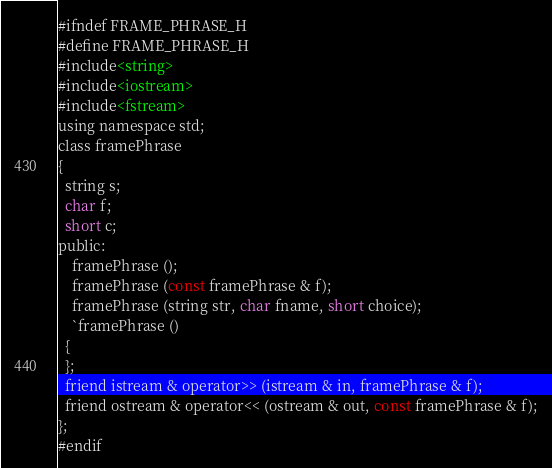Convert code to text. <code><loc_0><loc_0><loc_500><loc_500><_C_>#ifndef FRAME_PHRASE_H
#define FRAME_PHRASE_H
#include<string>
#include<iostream>
#include<fstream>
using namespace std;
class framePhrase
{
  string s;
  char f;
  short c;
public:
    framePhrase ();
    framePhrase (const framePhrase & f);
    framePhrase (string str, char fname, short choice);
    `framePhrase ()
  {
  };
  friend istream & operator>> (istream & in, framePhrase & f);
  friend ostream & operator<< (ostream & out, const framePhrase & f);
};
#endif
</code> 